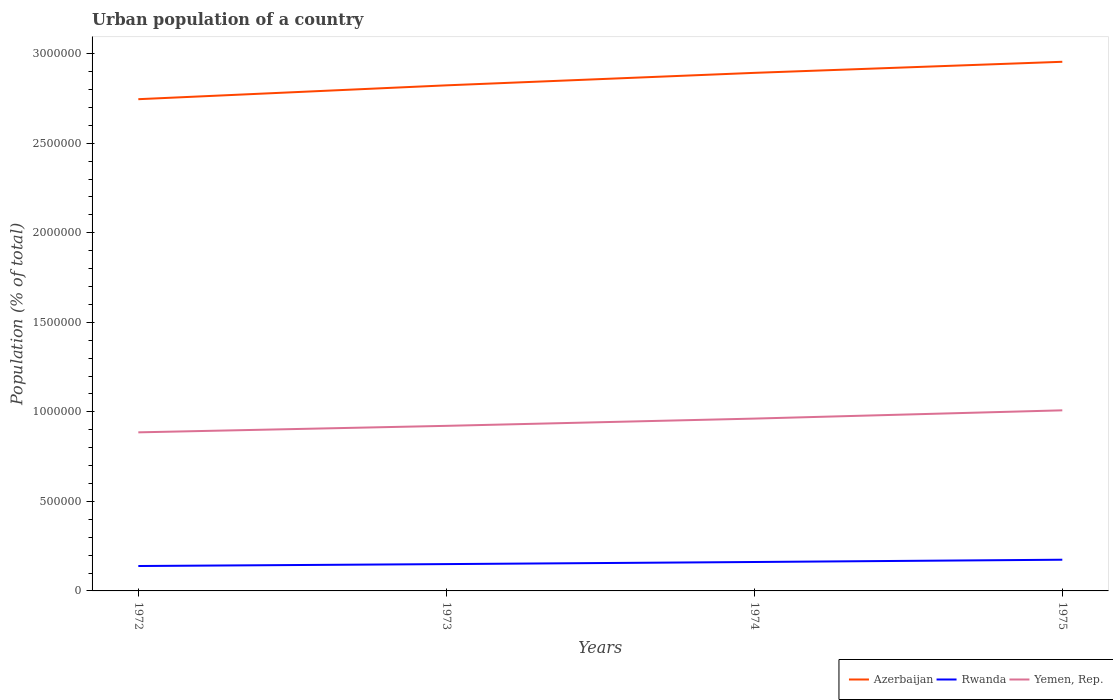How many different coloured lines are there?
Give a very brief answer. 3. Is the number of lines equal to the number of legend labels?
Your answer should be compact. Yes. Across all years, what is the maximum urban population in Rwanda?
Offer a very short reply. 1.39e+05. What is the total urban population in Yemen, Rep. in the graph?
Ensure brevity in your answer.  -7.68e+04. What is the difference between the highest and the second highest urban population in Yemen, Rep.?
Give a very brief answer. 1.23e+05. What is the difference between the highest and the lowest urban population in Azerbaijan?
Offer a terse response. 2. Is the urban population in Rwanda strictly greater than the urban population in Azerbaijan over the years?
Offer a very short reply. Yes. How many years are there in the graph?
Ensure brevity in your answer.  4. What is the difference between two consecutive major ticks on the Y-axis?
Your answer should be very brief. 5.00e+05. Does the graph contain any zero values?
Your answer should be compact. No. Where does the legend appear in the graph?
Give a very brief answer. Bottom right. What is the title of the graph?
Your answer should be compact. Urban population of a country. What is the label or title of the X-axis?
Your response must be concise. Years. What is the label or title of the Y-axis?
Make the answer very short. Population (% of total). What is the Population (% of total) of Azerbaijan in 1972?
Give a very brief answer. 2.75e+06. What is the Population (% of total) of Rwanda in 1972?
Offer a terse response. 1.39e+05. What is the Population (% of total) in Yemen, Rep. in 1972?
Ensure brevity in your answer.  8.86e+05. What is the Population (% of total) in Azerbaijan in 1973?
Keep it short and to the point. 2.82e+06. What is the Population (% of total) in Rwanda in 1973?
Offer a terse response. 1.50e+05. What is the Population (% of total) in Yemen, Rep. in 1973?
Your answer should be compact. 9.22e+05. What is the Population (% of total) of Azerbaijan in 1974?
Give a very brief answer. 2.89e+06. What is the Population (% of total) in Rwanda in 1974?
Provide a short and direct response. 1.62e+05. What is the Population (% of total) of Yemen, Rep. in 1974?
Make the answer very short. 9.62e+05. What is the Population (% of total) of Azerbaijan in 1975?
Your answer should be very brief. 2.95e+06. What is the Population (% of total) in Rwanda in 1975?
Offer a terse response. 1.74e+05. What is the Population (% of total) of Yemen, Rep. in 1975?
Make the answer very short. 1.01e+06. Across all years, what is the maximum Population (% of total) in Azerbaijan?
Provide a succinct answer. 2.95e+06. Across all years, what is the maximum Population (% of total) in Rwanda?
Offer a very short reply. 1.74e+05. Across all years, what is the maximum Population (% of total) in Yemen, Rep.?
Ensure brevity in your answer.  1.01e+06. Across all years, what is the minimum Population (% of total) in Azerbaijan?
Provide a short and direct response. 2.75e+06. Across all years, what is the minimum Population (% of total) of Rwanda?
Provide a short and direct response. 1.39e+05. Across all years, what is the minimum Population (% of total) of Yemen, Rep.?
Give a very brief answer. 8.86e+05. What is the total Population (% of total) in Azerbaijan in the graph?
Provide a succinct answer. 1.14e+07. What is the total Population (% of total) in Rwanda in the graph?
Provide a short and direct response. 6.25e+05. What is the total Population (% of total) of Yemen, Rep. in the graph?
Make the answer very short. 3.78e+06. What is the difference between the Population (% of total) in Azerbaijan in 1972 and that in 1973?
Your answer should be compact. -7.73e+04. What is the difference between the Population (% of total) of Rwanda in 1972 and that in 1973?
Provide a short and direct response. -1.07e+04. What is the difference between the Population (% of total) in Yemen, Rep. in 1972 and that in 1973?
Offer a terse response. -3.63e+04. What is the difference between the Population (% of total) of Azerbaijan in 1972 and that in 1974?
Provide a short and direct response. -1.47e+05. What is the difference between the Population (% of total) in Rwanda in 1972 and that in 1974?
Keep it short and to the point. -2.24e+04. What is the difference between the Population (% of total) of Yemen, Rep. in 1972 and that in 1974?
Make the answer very short. -7.68e+04. What is the difference between the Population (% of total) of Azerbaijan in 1972 and that in 1975?
Give a very brief answer. -2.09e+05. What is the difference between the Population (% of total) of Rwanda in 1972 and that in 1975?
Provide a short and direct response. -3.52e+04. What is the difference between the Population (% of total) of Yemen, Rep. in 1972 and that in 1975?
Keep it short and to the point. -1.23e+05. What is the difference between the Population (% of total) in Azerbaijan in 1973 and that in 1974?
Your response must be concise. -6.97e+04. What is the difference between the Population (% of total) in Rwanda in 1973 and that in 1974?
Keep it short and to the point. -1.17e+04. What is the difference between the Population (% of total) of Yemen, Rep. in 1973 and that in 1974?
Ensure brevity in your answer.  -4.05e+04. What is the difference between the Population (% of total) in Azerbaijan in 1973 and that in 1975?
Keep it short and to the point. -1.32e+05. What is the difference between the Population (% of total) in Rwanda in 1973 and that in 1975?
Your answer should be compact. -2.45e+04. What is the difference between the Population (% of total) in Yemen, Rep. in 1973 and that in 1975?
Give a very brief answer. -8.66e+04. What is the difference between the Population (% of total) of Azerbaijan in 1974 and that in 1975?
Ensure brevity in your answer.  -6.18e+04. What is the difference between the Population (% of total) in Rwanda in 1974 and that in 1975?
Offer a very short reply. -1.28e+04. What is the difference between the Population (% of total) of Yemen, Rep. in 1974 and that in 1975?
Your response must be concise. -4.61e+04. What is the difference between the Population (% of total) of Azerbaijan in 1972 and the Population (% of total) of Rwanda in 1973?
Your answer should be very brief. 2.60e+06. What is the difference between the Population (% of total) in Azerbaijan in 1972 and the Population (% of total) in Yemen, Rep. in 1973?
Offer a terse response. 1.82e+06. What is the difference between the Population (% of total) in Rwanda in 1972 and the Population (% of total) in Yemen, Rep. in 1973?
Give a very brief answer. -7.83e+05. What is the difference between the Population (% of total) in Azerbaijan in 1972 and the Population (% of total) in Rwanda in 1974?
Give a very brief answer. 2.58e+06. What is the difference between the Population (% of total) in Azerbaijan in 1972 and the Population (% of total) in Yemen, Rep. in 1974?
Make the answer very short. 1.78e+06. What is the difference between the Population (% of total) in Rwanda in 1972 and the Population (% of total) in Yemen, Rep. in 1974?
Keep it short and to the point. -8.23e+05. What is the difference between the Population (% of total) in Azerbaijan in 1972 and the Population (% of total) in Rwanda in 1975?
Make the answer very short. 2.57e+06. What is the difference between the Population (% of total) in Azerbaijan in 1972 and the Population (% of total) in Yemen, Rep. in 1975?
Offer a very short reply. 1.74e+06. What is the difference between the Population (% of total) in Rwanda in 1972 and the Population (% of total) in Yemen, Rep. in 1975?
Ensure brevity in your answer.  -8.69e+05. What is the difference between the Population (% of total) of Azerbaijan in 1973 and the Population (% of total) of Rwanda in 1974?
Ensure brevity in your answer.  2.66e+06. What is the difference between the Population (% of total) in Azerbaijan in 1973 and the Population (% of total) in Yemen, Rep. in 1974?
Ensure brevity in your answer.  1.86e+06. What is the difference between the Population (% of total) of Rwanda in 1973 and the Population (% of total) of Yemen, Rep. in 1974?
Your answer should be compact. -8.13e+05. What is the difference between the Population (% of total) of Azerbaijan in 1973 and the Population (% of total) of Rwanda in 1975?
Offer a terse response. 2.65e+06. What is the difference between the Population (% of total) in Azerbaijan in 1973 and the Population (% of total) in Yemen, Rep. in 1975?
Give a very brief answer. 1.81e+06. What is the difference between the Population (% of total) of Rwanda in 1973 and the Population (% of total) of Yemen, Rep. in 1975?
Your answer should be very brief. -8.59e+05. What is the difference between the Population (% of total) in Azerbaijan in 1974 and the Population (% of total) in Rwanda in 1975?
Provide a succinct answer. 2.72e+06. What is the difference between the Population (% of total) of Azerbaijan in 1974 and the Population (% of total) of Yemen, Rep. in 1975?
Keep it short and to the point. 1.88e+06. What is the difference between the Population (% of total) in Rwanda in 1974 and the Population (% of total) in Yemen, Rep. in 1975?
Your response must be concise. -8.47e+05. What is the average Population (% of total) of Azerbaijan per year?
Provide a short and direct response. 2.85e+06. What is the average Population (% of total) in Rwanda per year?
Ensure brevity in your answer.  1.56e+05. What is the average Population (% of total) in Yemen, Rep. per year?
Offer a very short reply. 9.45e+05. In the year 1972, what is the difference between the Population (% of total) in Azerbaijan and Population (% of total) in Rwanda?
Make the answer very short. 2.61e+06. In the year 1972, what is the difference between the Population (% of total) in Azerbaijan and Population (% of total) in Yemen, Rep.?
Your answer should be very brief. 1.86e+06. In the year 1972, what is the difference between the Population (% of total) of Rwanda and Population (% of total) of Yemen, Rep.?
Provide a succinct answer. -7.47e+05. In the year 1973, what is the difference between the Population (% of total) in Azerbaijan and Population (% of total) in Rwanda?
Give a very brief answer. 2.67e+06. In the year 1973, what is the difference between the Population (% of total) in Azerbaijan and Population (% of total) in Yemen, Rep.?
Make the answer very short. 1.90e+06. In the year 1973, what is the difference between the Population (% of total) of Rwanda and Population (% of total) of Yemen, Rep.?
Your answer should be very brief. -7.72e+05. In the year 1974, what is the difference between the Population (% of total) in Azerbaijan and Population (% of total) in Rwanda?
Keep it short and to the point. 2.73e+06. In the year 1974, what is the difference between the Population (% of total) in Azerbaijan and Population (% of total) in Yemen, Rep.?
Your answer should be compact. 1.93e+06. In the year 1974, what is the difference between the Population (% of total) of Rwanda and Population (% of total) of Yemen, Rep.?
Your response must be concise. -8.01e+05. In the year 1975, what is the difference between the Population (% of total) of Azerbaijan and Population (% of total) of Rwanda?
Your response must be concise. 2.78e+06. In the year 1975, what is the difference between the Population (% of total) of Azerbaijan and Population (% of total) of Yemen, Rep.?
Your answer should be very brief. 1.95e+06. In the year 1975, what is the difference between the Population (% of total) in Rwanda and Population (% of total) in Yemen, Rep.?
Make the answer very short. -8.34e+05. What is the ratio of the Population (% of total) of Azerbaijan in 1972 to that in 1973?
Provide a short and direct response. 0.97. What is the ratio of the Population (% of total) of Rwanda in 1972 to that in 1973?
Provide a succinct answer. 0.93. What is the ratio of the Population (% of total) in Yemen, Rep. in 1972 to that in 1973?
Offer a very short reply. 0.96. What is the ratio of the Population (% of total) of Azerbaijan in 1972 to that in 1974?
Provide a succinct answer. 0.95. What is the ratio of the Population (% of total) of Rwanda in 1972 to that in 1974?
Ensure brevity in your answer.  0.86. What is the ratio of the Population (% of total) in Yemen, Rep. in 1972 to that in 1974?
Keep it short and to the point. 0.92. What is the ratio of the Population (% of total) of Azerbaijan in 1972 to that in 1975?
Offer a terse response. 0.93. What is the ratio of the Population (% of total) in Rwanda in 1972 to that in 1975?
Keep it short and to the point. 0.8. What is the ratio of the Population (% of total) in Yemen, Rep. in 1972 to that in 1975?
Provide a short and direct response. 0.88. What is the ratio of the Population (% of total) in Azerbaijan in 1973 to that in 1974?
Your answer should be compact. 0.98. What is the ratio of the Population (% of total) of Rwanda in 1973 to that in 1974?
Provide a succinct answer. 0.93. What is the ratio of the Population (% of total) in Yemen, Rep. in 1973 to that in 1974?
Keep it short and to the point. 0.96. What is the ratio of the Population (% of total) of Azerbaijan in 1973 to that in 1975?
Your answer should be very brief. 0.96. What is the ratio of the Population (% of total) in Rwanda in 1973 to that in 1975?
Give a very brief answer. 0.86. What is the ratio of the Population (% of total) of Yemen, Rep. in 1973 to that in 1975?
Make the answer very short. 0.91. What is the ratio of the Population (% of total) of Azerbaijan in 1974 to that in 1975?
Provide a succinct answer. 0.98. What is the ratio of the Population (% of total) of Rwanda in 1974 to that in 1975?
Provide a succinct answer. 0.93. What is the ratio of the Population (% of total) of Yemen, Rep. in 1974 to that in 1975?
Your answer should be very brief. 0.95. What is the difference between the highest and the second highest Population (% of total) of Azerbaijan?
Your response must be concise. 6.18e+04. What is the difference between the highest and the second highest Population (% of total) in Rwanda?
Your answer should be compact. 1.28e+04. What is the difference between the highest and the second highest Population (% of total) in Yemen, Rep.?
Ensure brevity in your answer.  4.61e+04. What is the difference between the highest and the lowest Population (% of total) in Azerbaijan?
Offer a very short reply. 2.09e+05. What is the difference between the highest and the lowest Population (% of total) in Rwanda?
Your answer should be very brief. 3.52e+04. What is the difference between the highest and the lowest Population (% of total) in Yemen, Rep.?
Keep it short and to the point. 1.23e+05. 